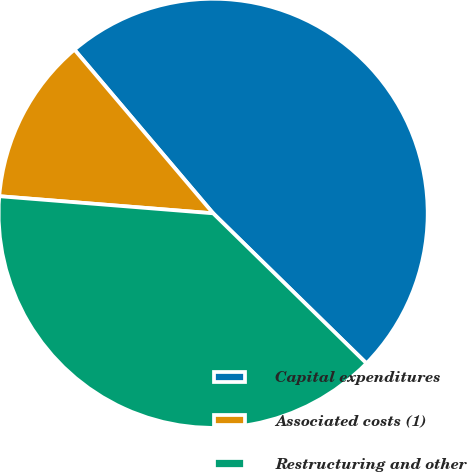<chart> <loc_0><loc_0><loc_500><loc_500><pie_chart><fcel>Capital expenditures<fcel>Associated costs (1)<fcel>Restructuring and other<nl><fcel>48.51%<fcel>12.54%<fcel>38.94%<nl></chart> 